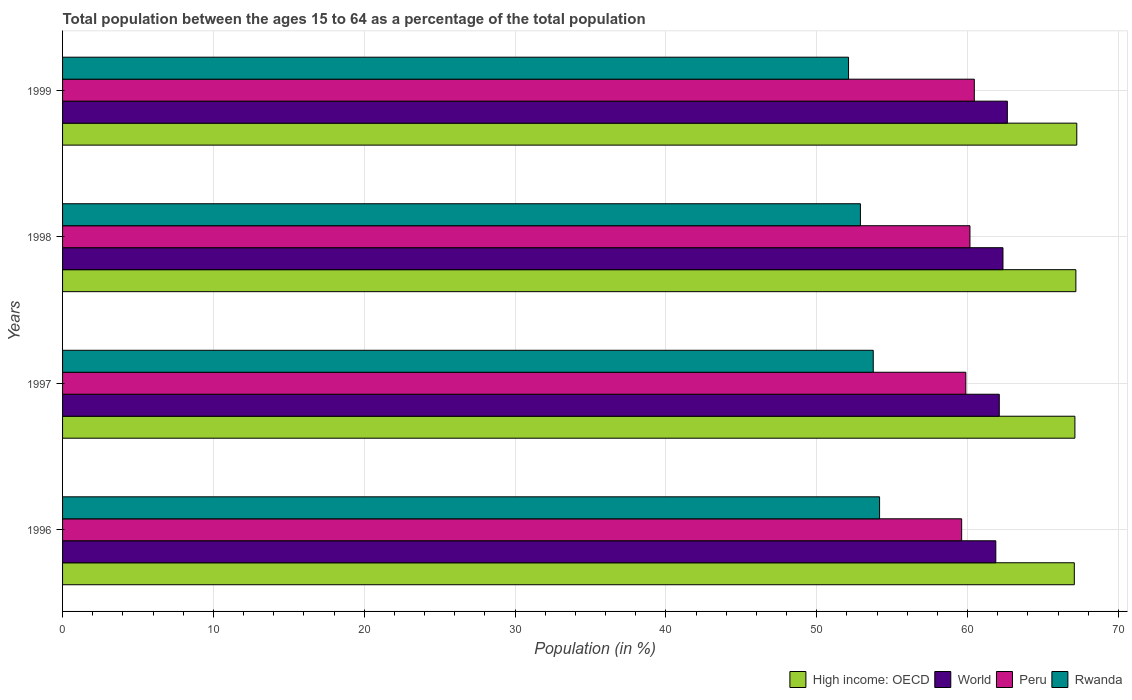How many different coloured bars are there?
Offer a terse response. 4. How many bars are there on the 2nd tick from the top?
Keep it short and to the point. 4. How many bars are there on the 4th tick from the bottom?
Provide a succinct answer. 4. What is the label of the 4th group of bars from the top?
Offer a very short reply. 1996. In how many cases, is the number of bars for a given year not equal to the number of legend labels?
Your answer should be compact. 0. What is the percentage of the population ages 15 to 64 in High income: OECD in 1996?
Keep it short and to the point. 67.08. Across all years, what is the maximum percentage of the population ages 15 to 64 in Peru?
Offer a terse response. 60.44. Across all years, what is the minimum percentage of the population ages 15 to 64 in World?
Your response must be concise. 61.87. In which year was the percentage of the population ages 15 to 64 in Rwanda maximum?
Keep it short and to the point. 1996. In which year was the percentage of the population ages 15 to 64 in Rwanda minimum?
Your answer should be very brief. 1999. What is the total percentage of the population ages 15 to 64 in World in the graph?
Keep it short and to the point. 248.95. What is the difference between the percentage of the population ages 15 to 64 in Peru in 1996 and that in 1999?
Keep it short and to the point. -0.84. What is the difference between the percentage of the population ages 15 to 64 in Peru in 1996 and the percentage of the population ages 15 to 64 in High income: OECD in 1998?
Your response must be concise. -7.57. What is the average percentage of the population ages 15 to 64 in High income: OECD per year?
Offer a very short reply. 67.15. In the year 1997, what is the difference between the percentage of the population ages 15 to 64 in High income: OECD and percentage of the population ages 15 to 64 in Peru?
Your answer should be compact. 7.23. What is the ratio of the percentage of the population ages 15 to 64 in Peru in 1997 to that in 1998?
Keep it short and to the point. 1. Is the percentage of the population ages 15 to 64 in High income: OECD in 1996 less than that in 1999?
Your answer should be compact. Yes. Is the difference between the percentage of the population ages 15 to 64 in High income: OECD in 1996 and 1998 greater than the difference between the percentage of the population ages 15 to 64 in Peru in 1996 and 1998?
Keep it short and to the point. Yes. What is the difference between the highest and the second highest percentage of the population ages 15 to 64 in High income: OECD?
Give a very brief answer. 0.06. What is the difference between the highest and the lowest percentage of the population ages 15 to 64 in Rwanda?
Your answer should be very brief. 2.06. Is the sum of the percentage of the population ages 15 to 64 in Peru in 1996 and 1997 greater than the maximum percentage of the population ages 15 to 64 in World across all years?
Offer a terse response. Yes. What does the 4th bar from the top in 1997 represents?
Ensure brevity in your answer.  High income: OECD. What does the 2nd bar from the bottom in 1999 represents?
Your response must be concise. World. Is it the case that in every year, the sum of the percentage of the population ages 15 to 64 in Rwanda and percentage of the population ages 15 to 64 in Peru is greater than the percentage of the population ages 15 to 64 in High income: OECD?
Your answer should be compact. Yes. How many years are there in the graph?
Keep it short and to the point. 4. Does the graph contain any zero values?
Your answer should be very brief. No. Where does the legend appear in the graph?
Ensure brevity in your answer.  Bottom right. What is the title of the graph?
Keep it short and to the point. Total population between the ages 15 to 64 as a percentage of the total population. What is the label or title of the X-axis?
Keep it short and to the point. Population (in %). What is the Population (in %) of High income: OECD in 1996?
Offer a terse response. 67.08. What is the Population (in %) in World in 1996?
Offer a very short reply. 61.87. What is the Population (in %) in Peru in 1996?
Provide a succinct answer. 59.61. What is the Population (in %) of Rwanda in 1996?
Give a very brief answer. 54.16. What is the Population (in %) of High income: OECD in 1997?
Provide a succinct answer. 67.11. What is the Population (in %) in World in 1997?
Make the answer very short. 62.1. What is the Population (in %) of Peru in 1997?
Offer a terse response. 59.88. What is the Population (in %) of Rwanda in 1997?
Ensure brevity in your answer.  53.75. What is the Population (in %) of High income: OECD in 1998?
Your response must be concise. 67.18. What is the Population (in %) of World in 1998?
Your answer should be very brief. 62.35. What is the Population (in %) in Peru in 1998?
Give a very brief answer. 60.16. What is the Population (in %) in Rwanda in 1998?
Give a very brief answer. 52.9. What is the Population (in %) of High income: OECD in 1999?
Keep it short and to the point. 67.24. What is the Population (in %) in World in 1999?
Offer a very short reply. 62.64. What is the Population (in %) in Peru in 1999?
Offer a very short reply. 60.44. What is the Population (in %) of Rwanda in 1999?
Your response must be concise. 52.11. Across all years, what is the maximum Population (in %) of High income: OECD?
Offer a very short reply. 67.24. Across all years, what is the maximum Population (in %) in World?
Make the answer very short. 62.64. Across all years, what is the maximum Population (in %) of Peru?
Make the answer very short. 60.44. Across all years, what is the maximum Population (in %) in Rwanda?
Make the answer very short. 54.16. Across all years, what is the minimum Population (in %) of High income: OECD?
Provide a succinct answer. 67.08. Across all years, what is the minimum Population (in %) of World?
Ensure brevity in your answer.  61.87. Across all years, what is the minimum Population (in %) of Peru?
Keep it short and to the point. 59.61. Across all years, what is the minimum Population (in %) of Rwanda?
Your answer should be very brief. 52.11. What is the total Population (in %) in High income: OECD in the graph?
Provide a succinct answer. 268.61. What is the total Population (in %) of World in the graph?
Make the answer very short. 248.95. What is the total Population (in %) in Peru in the graph?
Give a very brief answer. 240.09. What is the total Population (in %) in Rwanda in the graph?
Give a very brief answer. 212.91. What is the difference between the Population (in %) of High income: OECD in 1996 and that in 1997?
Offer a terse response. -0.04. What is the difference between the Population (in %) in World in 1996 and that in 1997?
Provide a short and direct response. -0.23. What is the difference between the Population (in %) of Peru in 1996 and that in 1997?
Provide a short and direct response. -0.28. What is the difference between the Population (in %) of Rwanda in 1996 and that in 1997?
Ensure brevity in your answer.  0.42. What is the difference between the Population (in %) in High income: OECD in 1996 and that in 1998?
Provide a short and direct response. -0.1. What is the difference between the Population (in %) in World in 1996 and that in 1998?
Your answer should be compact. -0.47. What is the difference between the Population (in %) of Peru in 1996 and that in 1998?
Provide a succinct answer. -0.55. What is the difference between the Population (in %) in Rwanda in 1996 and that in 1998?
Provide a short and direct response. 1.27. What is the difference between the Population (in %) in High income: OECD in 1996 and that in 1999?
Offer a terse response. -0.16. What is the difference between the Population (in %) of World in 1996 and that in 1999?
Your response must be concise. -0.77. What is the difference between the Population (in %) in Peru in 1996 and that in 1999?
Give a very brief answer. -0.84. What is the difference between the Population (in %) in Rwanda in 1996 and that in 1999?
Provide a short and direct response. 2.06. What is the difference between the Population (in %) in High income: OECD in 1997 and that in 1998?
Offer a terse response. -0.06. What is the difference between the Population (in %) of World in 1997 and that in 1998?
Offer a terse response. -0.25. What is the difference between the Population (in %) of Peru in 1997 and that in 1998?
Make the answer very short. -0.27. What is the difference between the Population (in %) in Rwanda in 1997 and that in 1998?
Keep it short and to the point. 0.85. What is the difference between the Population (in %) in High income: OECD in 1997 and that in 1999?
Your answer should be very brief. -0.12. What is the difference between the Population (in %) of World in 1997 and that in 1999?
Ensure brevity in your answer.  -0.54. What is the difference between the Population (in %) of Peru in 1997 and that in 1999?
Provide a succinct answer. -0.56. What is the difference between the Population (in %) in Rwanda in 1997 and that in 1999?
Offer a very short reply. 1.64. What is the difference between the Population (in %) of High income: OECD in 1998 and that in 1999?
Your response must be concise. -0.06. What is the difference between the Population (in %) of World in 1998 and that in 1999?
Provide a succinct answer. -0.29. What is the difference between the Population (in %) in Peru in 1998 and that in 1999?
Make the answer very short. -0.29. What is the difference between the Population (in %) of Rwanda in 1998 and that in 1999?
Provide a succinct answer. 0.79. What is the difference between the Population (in %) in High income: OECD in 1996 and the Population (in %) in World in 1997?
Offer a terse response. 4.98. What is the difference between the Population (in %) in High income: OECD in 1996 and the Population (in %) in Peru in 1997?
Keep it short and to the point. 7.19. What is the difference between the Population (in %) in High income: OECD in 1996 and the Population (in %) in Rwanda in 1997?
Keep it short and to the point. 13.33. What is the difference between the Population (in %) in World in 1996 and the Population (in %) in Peru in 1997?
Provide a succinct answer. 1.99. What is the difference between the Population (in %) in World in 1996 and the Population (in %) in Rwanda in 1997?
Your answer should be compact. 8.13. What is the difference between the Population (in %) of Peru in 1996 and the Population (in %) of Rwanda in 1997?
Ensure brevity in your answer.  5.86. What is the difference between the Population (in %) of High income: OECD in 1996 and the Population (in %) of World in 1998?
Your response must be concise. 4.73. What is the difference between the Population (in %) of High income: OECD in 1996 and the Population (in %) of Peru in 1998?
Your answer should be compact. 6.92. What is the difference between the Population (in %) of High income: OECD in 1996 and the Population (in %) of Rwanda in 1998?
Provide a succinct answer. 14.18. What is the difference between the Population (in %) of World in 1996 and the Population (in %) of Peru in 1998?
Your answer should be compact. 1.71. What is the difference between the Population (in %) of World in 1996 and the Population (in %) of Rwanda in 1998?
Make the answer very short. 8.98. What is the difference between the Population (in %) in Peru in 1996 and the Population (in %) in Rwanda in 1998?
Keep it short and to the point. 6.71. What is the difference between the Population (in %) in High income: OECD in 1996 and the Population (in %) in World in 1999?
Offer a terse response. 4.44. What is the difference between the Population (in %) of High income: OECD in 1996 and the Population (in %) of Peru in 1999?
Make the answer very short. 6.63. What is the difference between the Population (in %) in High income: OECD in 1996 and the Population (in %) in Rwanda in 1999?
Your answer should be compact. 14.97. What is the difference between the Population (in %) of World in 1996 and the Population (in %) of Peru in 1999?
Provide a succinct answer. 1.43. What is the difference between the Population (in %) of World in 1996 and the Population (in %) of Rwanda in 1999?
Your response must be concise. 9.76. What is the difference between the Population (in %) of Peru in 1996 and the Population (in %) of Rwanda in 1999?
Offer a very short reply. 7.5. What is the difference between the Population (in %) of High income: OECD in 1997 and the Population (in %) of World in 1998?
Make the answer very short. 4.77. What is the difference between the Population (in %) of High income: OECD in 1997 and the Population (in %) of Peru in 1998?
Offer a terse response. 6.96. What is the difference between the Population (in %) of High income: OECD in 1997 and the Population (in %) of Rwanda in 1998?
Make the answer very short. 14.22. What is the difference between the Population (in %) in World in 1997 and the Population (in %) in Peru in 1998?
Ensure brevity in your answer.  1.94. What is the difference between the Population (in %) in World in 1997 and the Population (in %) in Rwanda in 1998?
Provide a short and direct response. 9.2. What is the difference between the Population (in %) in Peru in 1997 and the Population (in %) in Rwanda in 1998?
Your answer should be very brief. 6.99. What is the difference between the Population (in %) in High income: OECD in 1997 and the Population (in %) in World in 1999?
Your answer should be compact. 4.48. What is the difference between the Population (in %) of High income: OECD in 1997 and the Population (in %) of Peru in 1999?
Your response must be concise. 6.67. What is the difference between the Population (in %) of High income: OECD in 1997 and the Population (in %) of Rwanda in 1999?
Offer a terse response. 15.01. What is the difference between the Population (in %) in World in 1997 and the Population (in %) in Peru in 1999?
Your answer should be compact. 1.66. What is the difference between the Population (in %) of World in 1997 and the Population (in %) of Rwanda in 1999?
Offer a terse response. 9.99. What is the difference between the Population (in %) of Peru in 1997 and the Population (in %) of Rwanda in 1999?
Keep it short and to the point. 7.78. What is the difference between the Population (in %) of High income: OECD in 1998 and the Population (in %) of World in 1999?
Provide a succinct answer. 4.54. What is the difference between the Population (in %) in High income: OECD in 1998 and the Population (in %) in Peru in 1999?
Ensure brevity in your answer.  6.73. What is the difference between the Population (in %) of High income: OECD in 1998 and the Population (in %) of Rwanda in 1999?
Your answer should be compact. 15.07. What is the difference between the Population (in %) in World in 1998 and the Population (in %) in Peru in 1999?
Provide a succinct answer. 1.9. What is the difference between the Population (in %) in World in 1998 and the Population (in %) in Rwanda in 1999?
Provide a short and direct response. 10.24. What is the difference between the Population (in %) in Peru in 1998 and the Population (in %) in Rwanda in 1999?
Your response must be concise. 8.05. What is the average Population (in %) in High income: OECD per year?
Your answer should be compact. 67.15. What is the average Population (in %) of World per year?
Your answer should be compact. 62.24. What is the average Population (in %) of Peru per year?
Keep it short and to the point. 60.02. What is the average Population (in %) in Rwanda per year?
Provide a short and direct response. 53.23. In the year 1996, what is the difference between the Population (in %) of High income: OECD and Population (in %) of World?
Provide a succinct answer. 5.2. In the year 1996, what is the difference between the Population (in %) of High income: OECD and Population (in %) of Peru?
Ensure brevity in your answer.  7.47. In the year 1996, what is the difference between the Population (in %) of High income: OECD and Population (in %) of Rwanda?
Offer a terse response. 12.91. In the year 1996, what is the difference between the Population (in %) in World and Population (in %) in Peru?
Your answer should be very brief. 2.26. In the year 1996, what is the difference between the Population (in %) of World and Population (in %) of Rwanda?
Your answer should be compact. 7.71. In the year 1996, what is the difference between the Population (in %) of Peru and Population (in %) of Rwanda?
Provide a short and direct response. 5.44. In the year 1997, what is the difference between the Population (in %) of High income: OECD and Population (in %) of World?
Ensure brevity in your answer.  5.01. In the year 1997, what is the difference between the Population (in %) in High income: OECD and Population (in %) in Peru?
Provide a succinct answer. 7.23. In the year 1997, what is the difference between the Population (in %) of High income: OECD and Population (in %) of Rwanda?
Offer a terse response. 13.37. In the year 1997, what is the difference between the Population (in %) in World and Population (in %) in Peru?
Your answer should be compact. 2.22. In the year 1997, what is the difference between the Population (in %) of World and Population (in %) of Rwanda?
Your answer should be very brief. 8.35. In the year 1997, what is the difference between the Population (in %) in Peru and Population (in %) in Rwanda?
Make the answer very short. 6.14. In the year 1998, what is the difference between the Population (in %) in High income: OECD and Population (in %) in World?
Your response must be concise. 4.83. In the year 1998, what is the difference between the Population (in %) in High income: OECD and Population (in %) in Peru?
Offer a terse response. 7.02. In the year 1998, what is the difference between the Population (in %) of High income: OECD and Population (in %) of Rwanda?
Make the answer very short. 14.28. In the year 1998, what is the difference between the Population (in %) of World and Population (in %) of Peru?
Ensure brevity in your answer.  2.19. In the year 1998, what is the difference between the Population (in %) in World and Population (in %) in Rwanda?
Offer a very short reply. 9.45. In the year 1998, what is the difference between the Population (in %) in Peru and Population (in %) in Rwanda?
Offer a terse response. 7.26. In the year 1999, what is the difference between the Population (in %) of High income: OECD and Population (in %) of World?
Keep it short and to the point. 4.6. In the year 1999, what is the difference between the Population (in %) of High income: OECD and Population (in %) of Peru?
Offer a terse response. 6.79. In the year 1999, what is the difference between the Population (in %) of High income: OECD and Population (in %) of Rwanda?
Make the answer very short. 15.13. In the year 1999, what is the difference between the Population (in %) in World and Population (in %) in Peru?
Ensure brevity in your answer.  2.19. In the year 1999, what is the difference between the Population (in %) of World and Population (in %) of Rwanda?
Your answer should be compact. 10.53. In the year 1999, what is the difference between the Population (in %) of Peru and Population (in %) of Rwanda?
Provide a succinct answer. 8.34. What is the ratio of the Population (in %) of High income: OECD in 1996 to that in 1997?
Offer a terse response. 1. What is the ratio of the Population (in %) in World in 1996 to that in 1998?
Provide a short and direct response. 0.99. What is the ratio of the Population (in %) in Peru in 1996 to that in 1998?
Give a very brief answer. 0.99. What is the ratio of the Population (in %) of Rwanda in 1996 to that in 1998?
Your answer should be compact. 1.02. What is the ratio of the Population (in %) of Peru in 1996 to that in 1999?
Offer a very short reply. 0.99. What is the ratio of the Population (in %) in Rwanda in 1996 to that in 1999?
Make the answer very short. 1.04. What is the ratio of the Population (in %) of High income: OECD in 1997 to that in 1998?
Your answer should be very brief. 1. What is the ratio of the Population (in %) of World in 1997 to that in 1998?
Offer a very short reply. 1. What is the ratio of the Population (in %) of Peru in 1997 to that in 1998?
Your answer should be very brief. 1. What is the ratio of the Population (in %) in Rwanda in 1997 to that in 1998?
Your answer should be compact. 1.02. What is the ratio of the Population (in %) of World in 1997 to that in 1999?
Make the answer very short. 0.99. What is the ratio of the Population (in %) in Rwanda in 1997 to that in 1999?
Provide a succinct answer. 1.03. What is the ratio of the Population (in %) in Rwanda in 1998 to that in 1999?
Offer a very short reply. 1.02. What is the difference between the highest and the second highest Population (in %) of High income: OECD?
Offer a terse response. 0.06. What is the difference between the highest and the second highest Population (in %) in World?
Keep it short and to the point. 0.29. What is the difference between the highest and the second highest Population (in %) of Peru?
Give a very brief answer. 0.29. What is the difference between the highest and the second highest Population (in %) in Rwanda?
Ensure brevity in your answer.  0.42. What is the difference between the highest and the lowest Population (in %) in High income: OECD?
Provide a short and direct response. 0.16. What is the difference between the highest and the lowest Population (in %) of World?
Your answer should be very brief. 0.77. What is the difference between the highest and the lowest Population (in %) of Peru?
Your answer should be very brief. 0.84. What is the difference between the highest and the lowest Population (in %) of Rwanda?
Your answer should be very brief. 2.06. 